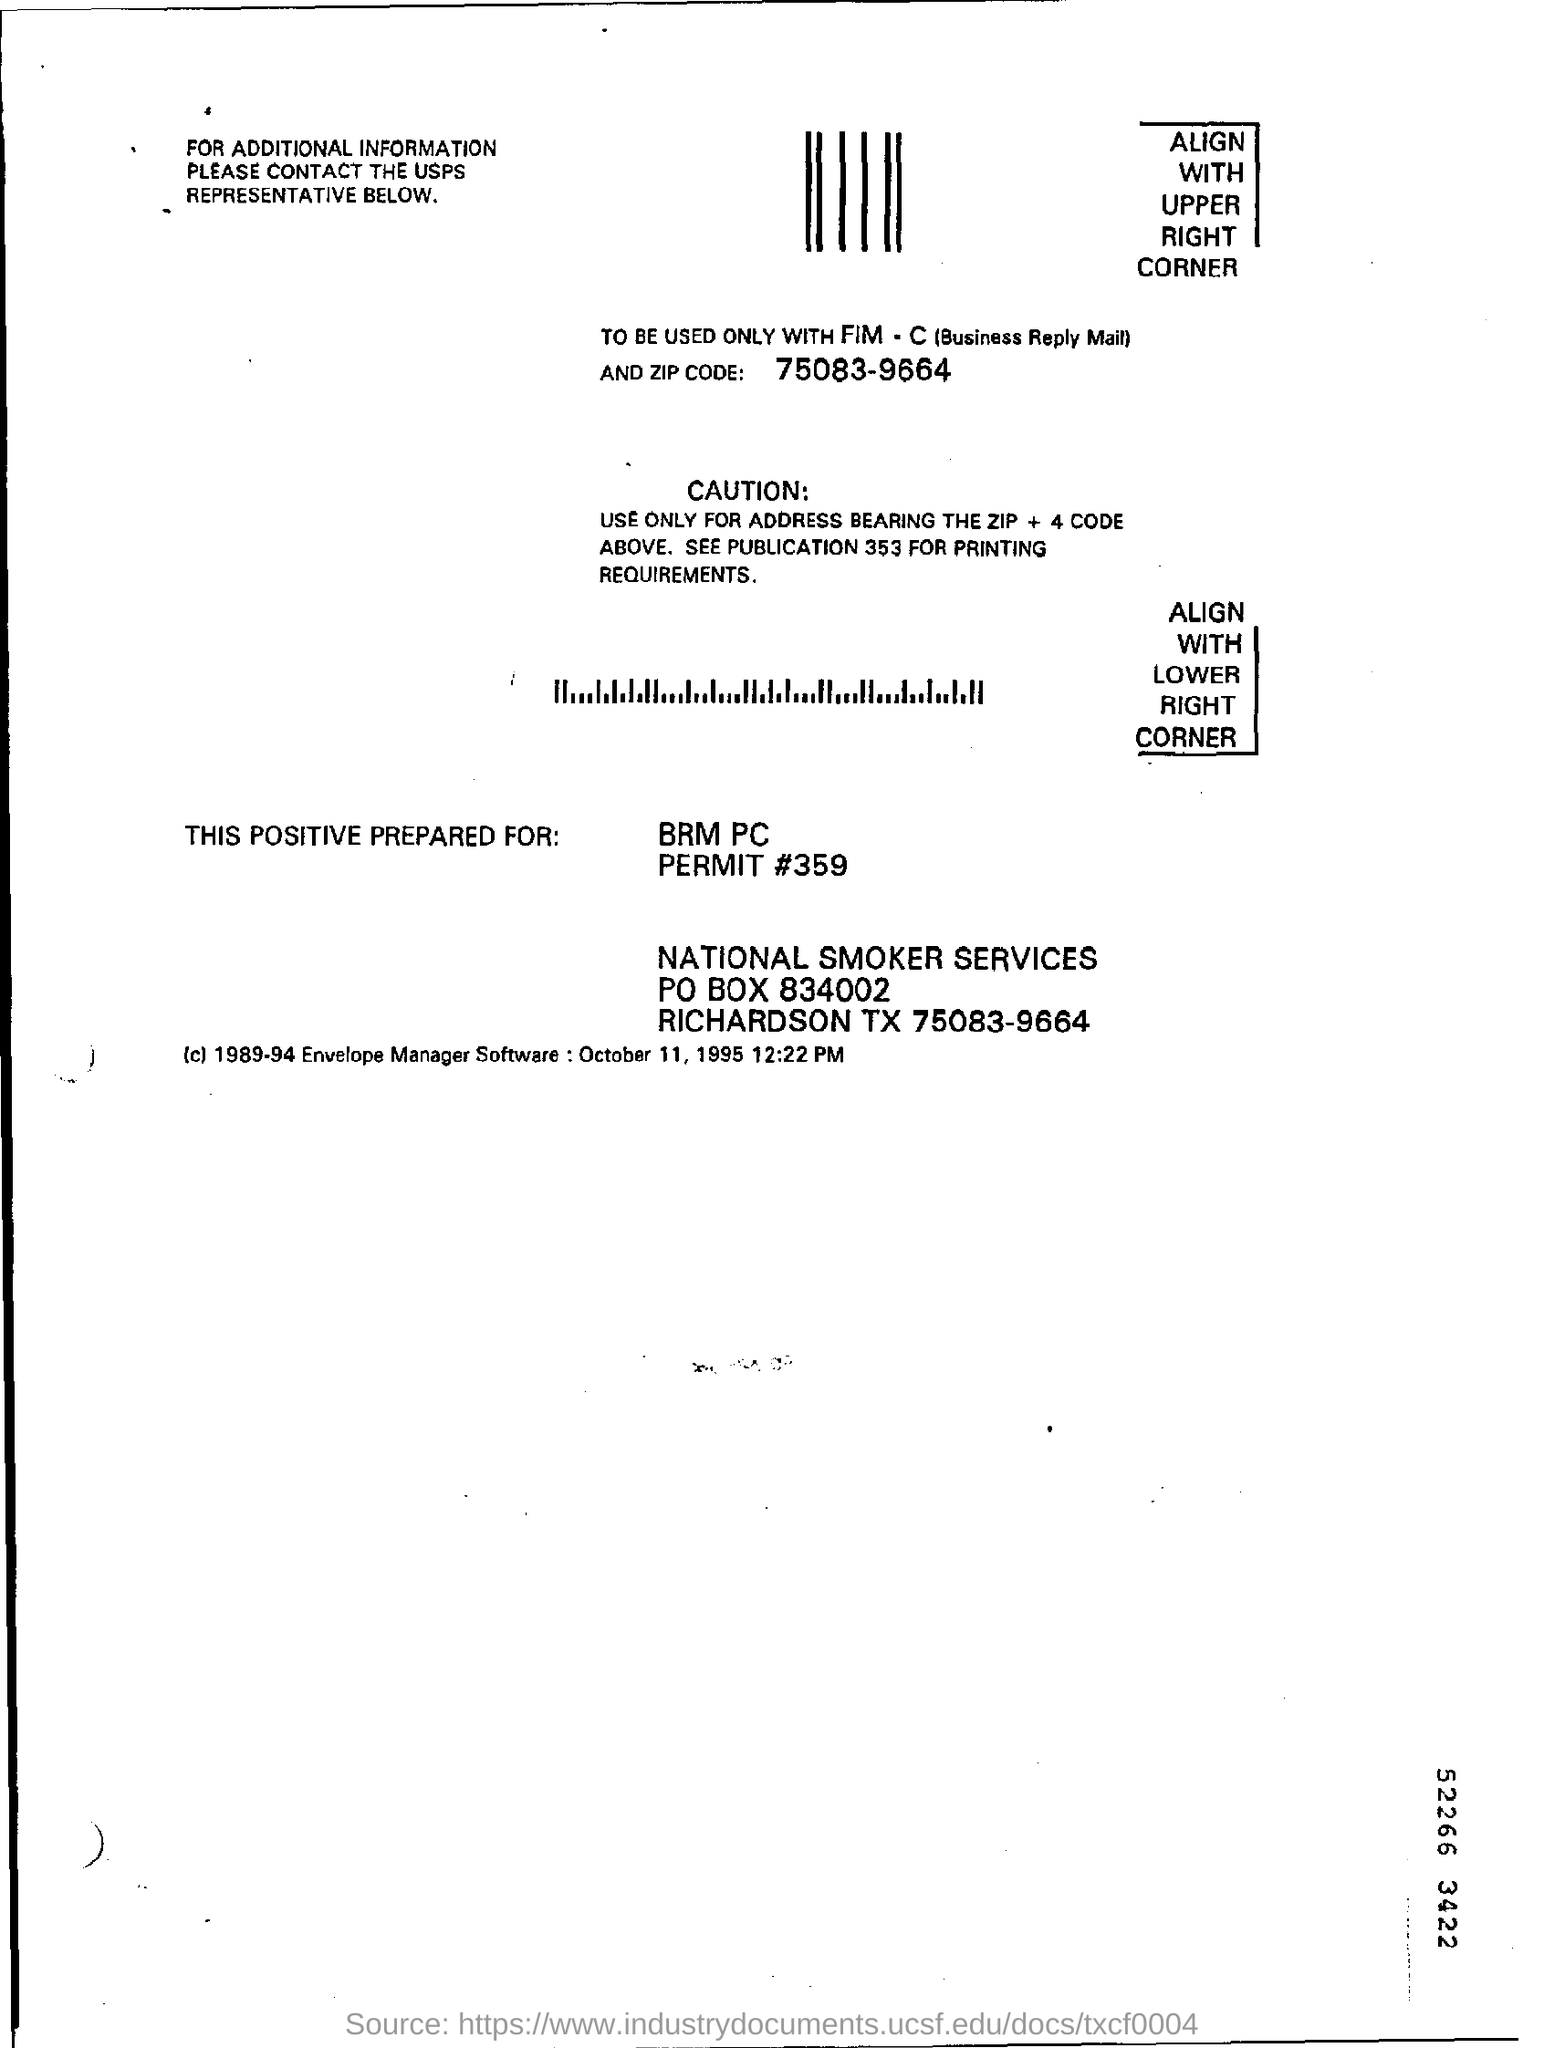Highlight a few significant elements in this photo. The zip code mentioned in the email is 75083-9664. The permit number is 359. The PO box number is 834002. 